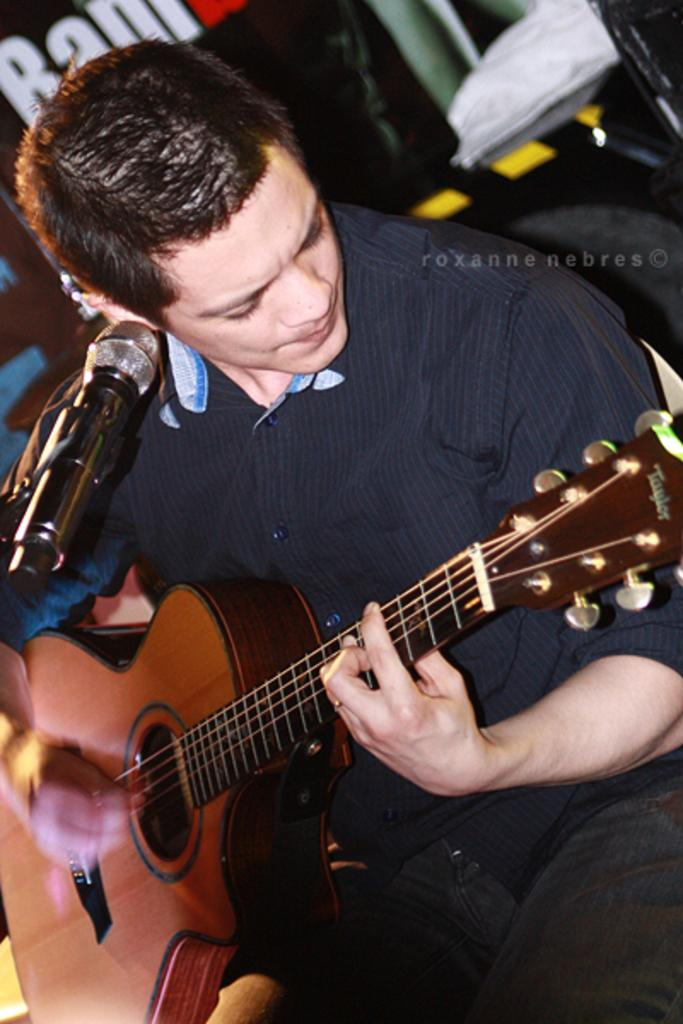What is the main subject of the image? The main subject of the image is a man. What is the man doing in the image? The man is sitting on a chair and playing an instrument in front of a microphone. Can you describe the background of the image? There is a chair and a hoarding in the background of the image. What type of underwear is the man wearing in the image? There is no information about the man's underwear in the image, so it cannot be determined. 